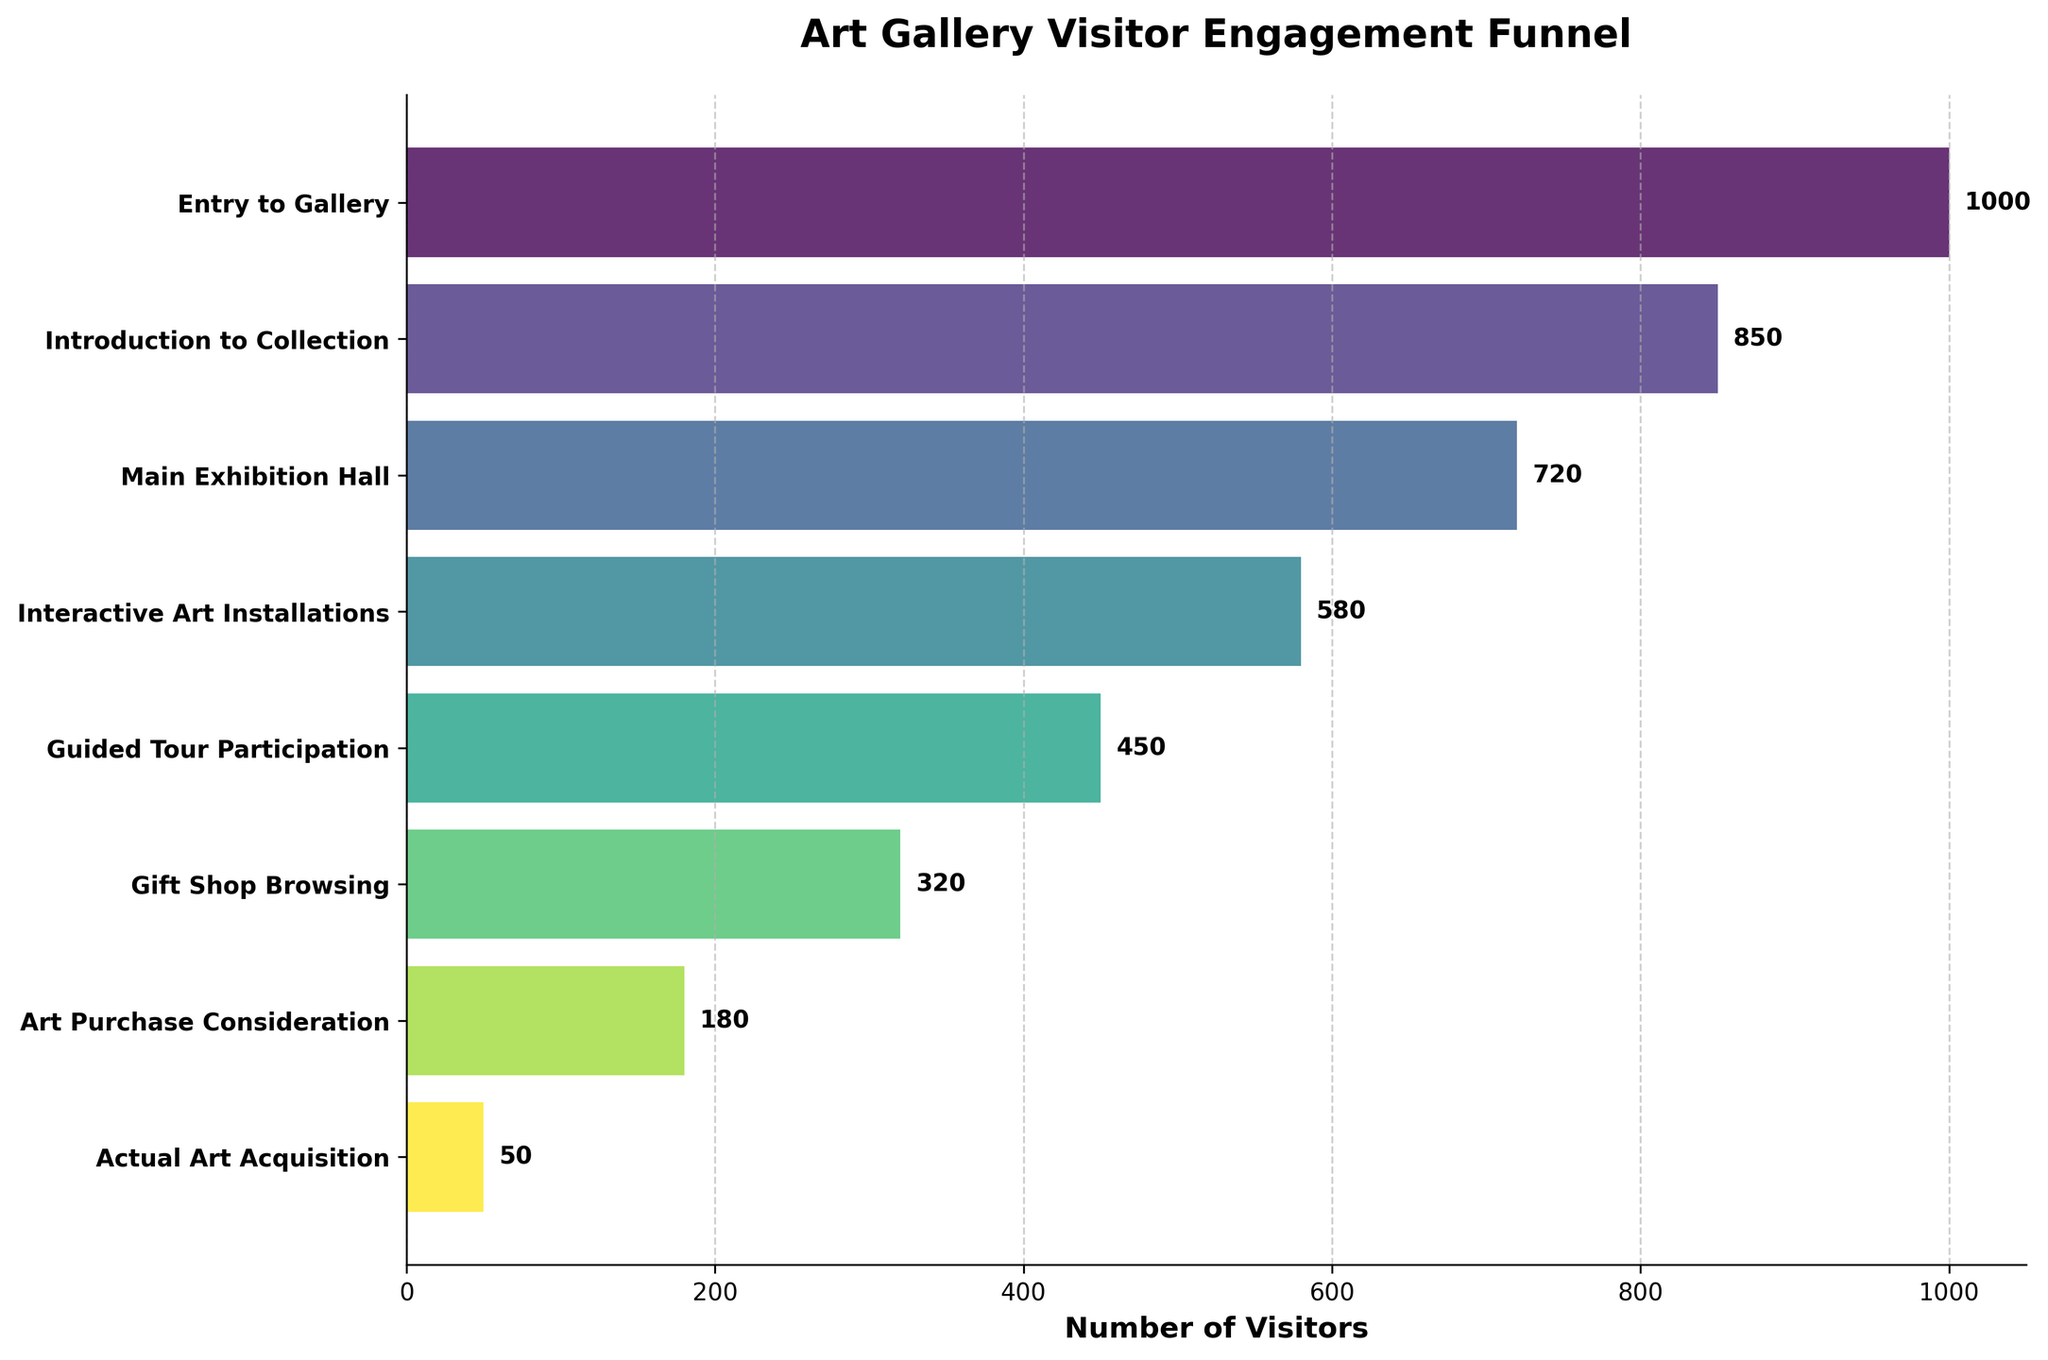what is the title of the chart? The title of the chart is displayed at the top of the figure in bold and larger font compared to other texts. This title provides a summary of what the figure is about.
Answer: Art Gallery Visitor Engagement Funnel How many stages are there in the Visitor Engagement Funnel? To determine the number of stages, count the distinct visual elements along the y-axis, which represent each stage.
Answer: 8 Which stage sees the biggest drop in visitors from the previous stage? To identify the stage with the biggest drop, compare the difference in visitor numbers between consecutive stages. The largest numerical drop will identify the stage in question.
Answer: Main Exhibition Hall to Interactive Art Installations How many visitors reached the Art Purchase Consideration stage? Locate the 'Art Purchase Consideration' stage on the y-axis and read the corresponding value on the x-axis indicating the number of visitors.
Answer: 180 By how many visitors did participation decrease from Entry to Gallery to Guided Tour Participation? Find the visitor numbers for both 'Entry to Gallery' and 'Guided Tour Participation', then subtract the latter from the former to get the difference. 1000 - 450 = 550
Answer: 550 What percentage of visitors who enter the gallery end up making an actual art acquisition? To find the percentage, divide the number of visitors making an 'Actual Art Acquisition' by the number of 'Entry to Gallery' visitors and then multiply by 100. (50 / 1000) * 100 = 5%
Answer: 5% Which stage has more visitors: Gift Shop Browsing or Interactive Art Installations? Compare the numbers of visitors at the 'Gift Shop Browsing' and ‘Interactive Art Installations' stages directly from the x-axis values.
Answer: Interactive Art Installations How many visitors do not proceed beyond the Main Exhibition Hall? Calculate the difference between the number of visitors at the 'Main Exhibition Hall' and those at the stage immediately following it. 720 - 580 = 140
Answer: 140 Rank the stages in descending order of visitor engagement. Arrange the stages based on the number of visitors in descending order, from highest to lowest.
Answer: Entry to Gallery, Introduction to Collection, Main Exhibition Hall, Interactive Art Installations, Guided Tour Participation, Gift Shop Browsing, Art Purchase Consideration, Actual Art Acquisition 